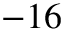Convert formula to latex. <formula><loc_0><loc_0><loc_500><loc_500>- 1 6</formula> 